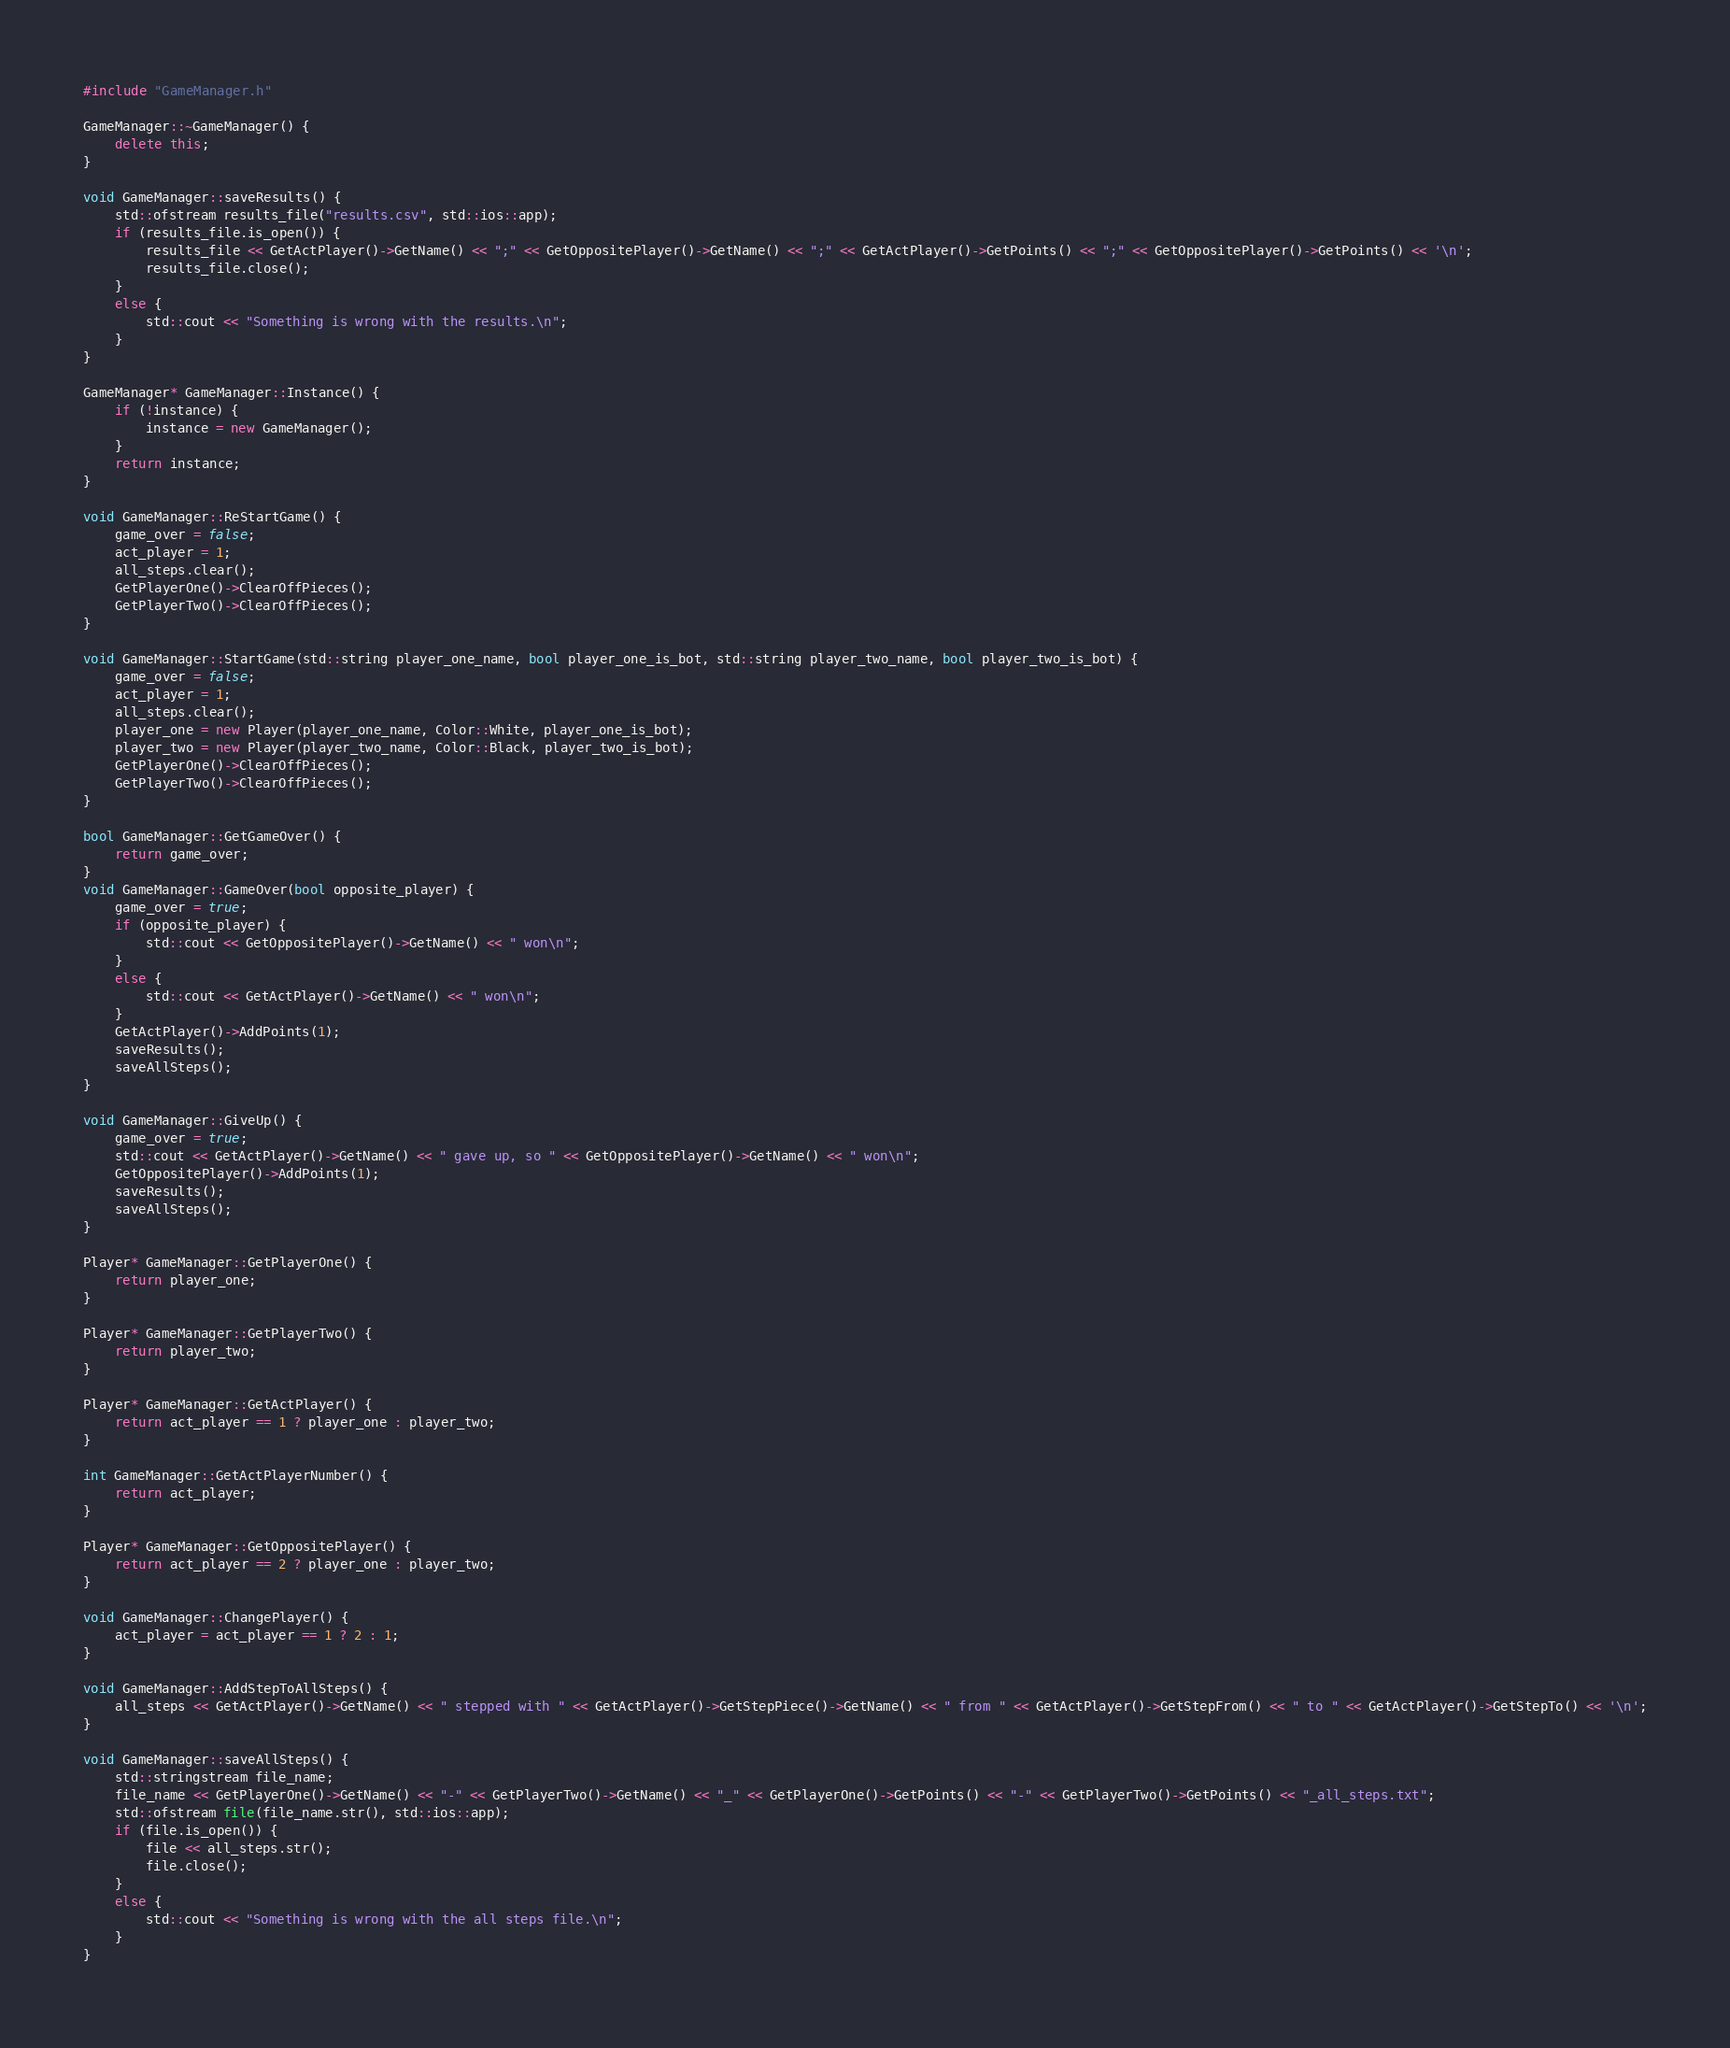<code> <loc_0><loc_0><loc_500><loc_500><_C++_>#include "GameManager.h"

GameManager::~GameManager() {
	delete this;
}

void GameManager::saveResults() {
	std::ofstream results_file("results.csv", std::ios::app);
	if (results_file.is_open()) {
		results_file << GetActPlayer()->GetName() << ";" << GetOppositePlayer()->GetName() << ";" << GetActPlayer()->GetPoints() << ";" << GetOppositePlayer()->GetPoints() << '\n';
		results_file.close();
	}
	else {
		std::cout << "Something is wrong with the results.\n";
	}
}

GameManager* GameManager::Instance() {
	if (!instance) {
		instance = new GameManager();
	}
	return instance;
}

void GameManager::ReStartGame() {
	game_over = false;
	act_player = 1;
	all_steps.clear();
	GetPlayerOne()->ClearOffPieces();
	GetPlayerTwo()->ClearOffPieces();
}

void GameManager::StartGame(std::string player_one_name, bool player_one_is_bot, std::string player_two_name, bool player_two_is_bot) {
	game_over = false;
	act_player = 1;
	all_steps.clear();
	player_one = new Player(player_one_name, Color::White, player_one_is_bot);
	player_two = new Player(player_two_name, Color::Black, player_two_is_bot);
	GetPlayerOne()->ClearOffPieces();
	GetPlayerTwo()->ClearOffPieces();
}

bool GameManager::GetGameOver() {
	return game_over;
}
void GameManager::GameOver(bool opposite_player) {
	game_over = true;
	if (opposite_player) {
		std::cout << GetOppositePlayer()->GetName() << " won\n";
	}
	else {
		std::cout << GetActPlayer()->GetName() << " won\n";
	}
	GetActPlayer()->AddPoints(1);
	saveResults();
	saveAllSteps();
}

void GameManager::GiveUp() {
	game_over = true;
	std::cout << GetActPlayer()->GetName() << " gave up, so " << GetOppositePlayer()->GetName() << " won\n";
	GetOppositePlayer()->AddPoints(1);
	saveResults();
	saveAllSteps();
}

Player* GameManager::GetPlayerOne() {
	return player_one;
}

Player* GameManager::GetPlayerTwo() {
	return player_two;
}

Player* GameManager::GetActPlayer() {
	return act_player == 1 ? player_one : player_two;
}

int GameManager::GetActPlayerNumber() {
	return act_player;
}

Player* GameManager::GetOppositePlayer() {
	return act_player == 2 ? player_one : player_two;
}

void GameManager::ChangePlayer() {
	act_player = act_player == 1 ? 2 : 1;
}

void GameManager::AddStepToAllSteps() {
	all_steps << GetActPlayer()->GetName() << " stepped with " << GetActPlayer()->GetStepPiece()->GetName() << " from " << GetActPlayer()->GetStepFrom() << " to " << GetActPlayer()->GetStepTo() << '\n';
}

void GameManager::saveAllSteps() {
	std::stringstream file_name;
	file_name << GetPlayerOne()->GetName() << "-" << GetPlayerTwo()->GetName() << "_" << GetPlayerOne()->GetPoints() << "-" << GetPlayerTwo()->GetPoints() << "_all_steps.txt";
	std::ofstream file(file_name.str(), std::ios::app);
	if (file.is_open()) {
		file << all_steps.str();
		file.close();
	}
	else {
		std::cout << "Something is wrong with the all steps file.\n";
	}
}</code> 